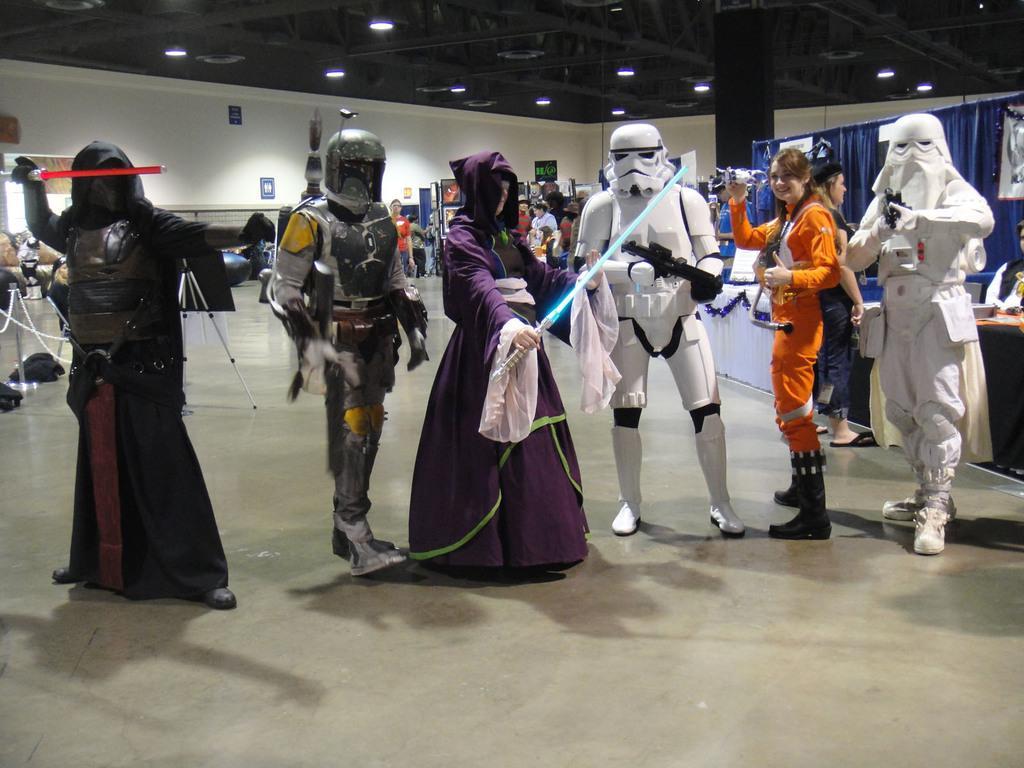In one or two sentences, can you explain what this image depicts? People are standing wearing different costumes. Behind them there are other people standing. There are lights on the top. 